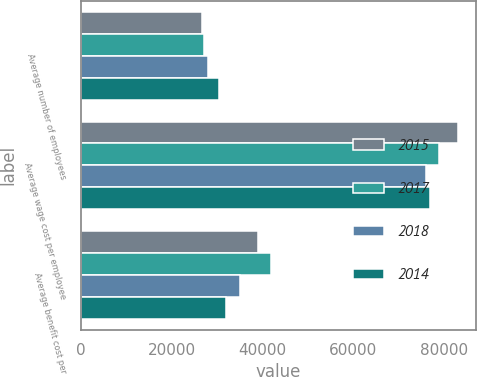Convert chart. <chart><loc_0><loc_0><loc_500><loc_500><stacked_bar_chart><ecel><fcel>Average number of employees<fcel>Average wage cost per employee<fcel>Average benefit cost per<nl><fcel>2015<fcel>26662<fcel>83000<fcel>39000<nl><fcel>2017<fcel>27110<fcel>79000<fcel>42000<nl><fcel>2018<fcel>28044<fcel>76000<fcel>35000<nl><fcel>2014<fcel>30456<fcel>77000<fcel>32000<nl></chart> 